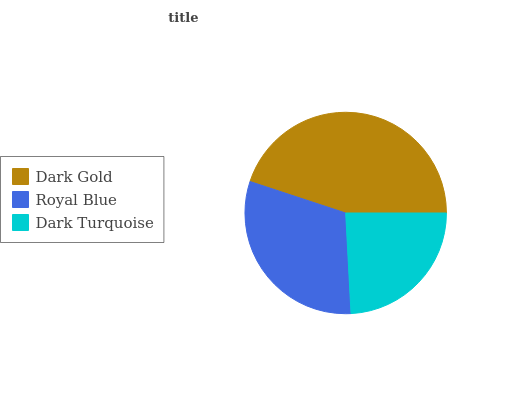Is Dark Turquoise the minimum?
Answer yes or no. Yes. Is Dark Gold the maximum?
Answer yes or no. Yes. Is Royal Blue the minimum?
Answer yes or no. No. Is Royal Blue the maximum?
Answer yes or no. No. Is Dark Gold greater than Royal Blue?
Answer yes or no. Yes. Is Royal Blue less than Dark Gold?
Answer yes or no. Yes. Is Royal Blue greater than Dark Gold?
Answer yes or no. No. Is Dark Gold less than Royal Blue?
Answer yes or no. No. Is Royal Blue the high median?
Answer yes or no. Yes. Is Royal Blue the low median?
Answer yes or no. Yes. Is Dark Turquoise the high median?
Answer yes or no. No. Is Dark Gold the low median?
Answer yes or no. No. 